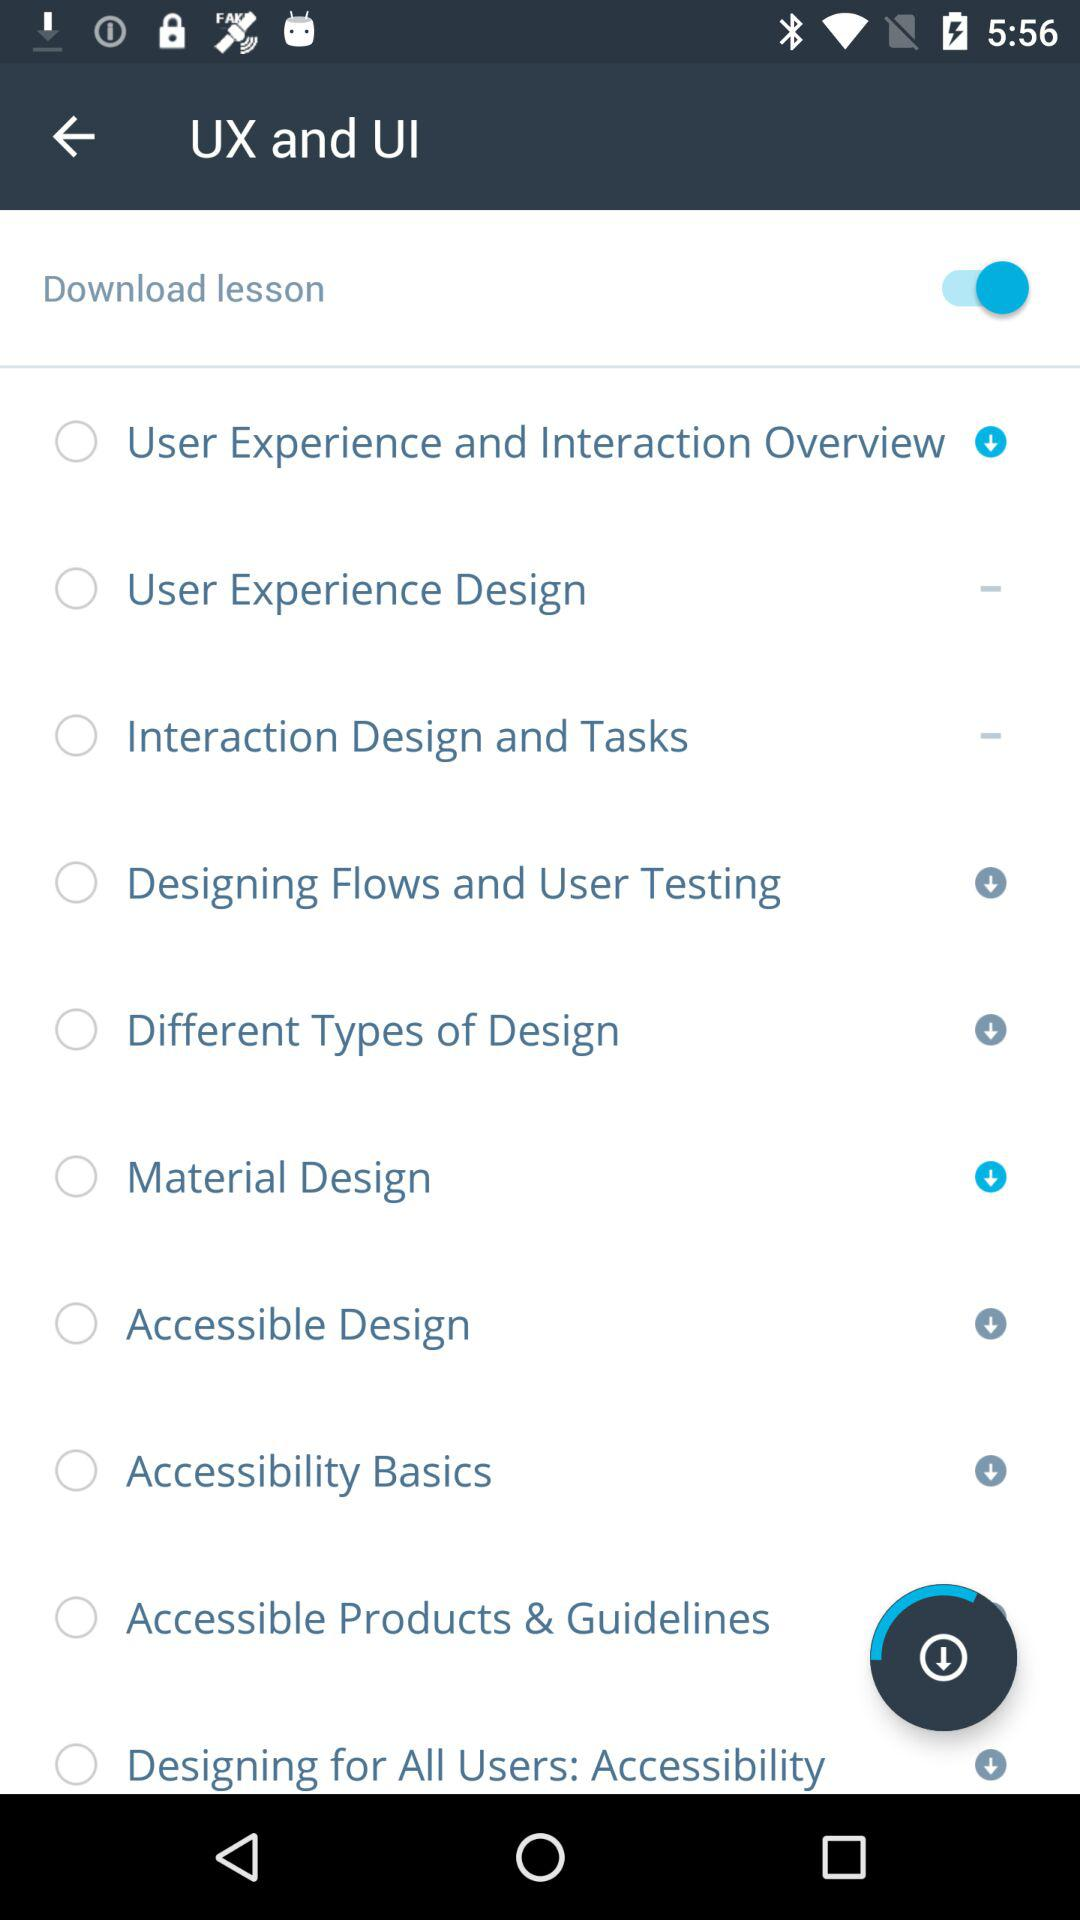What is the status of "Download lesson"? The status is "on". 